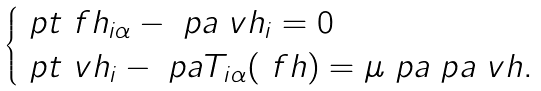<formula> <loc_0><loc_0><loc_500><loc_500>\begin{cases} \ p t \ f h _ { i \alpha } - \ p a \ v h _ { i } = 0 & \\ \ p t \ v h _ { i } - \ p a T _ { i \alpha } ( \ f h ) = \mu \ p a \ p a \ v h . & \\ \end{cases}</formula> 